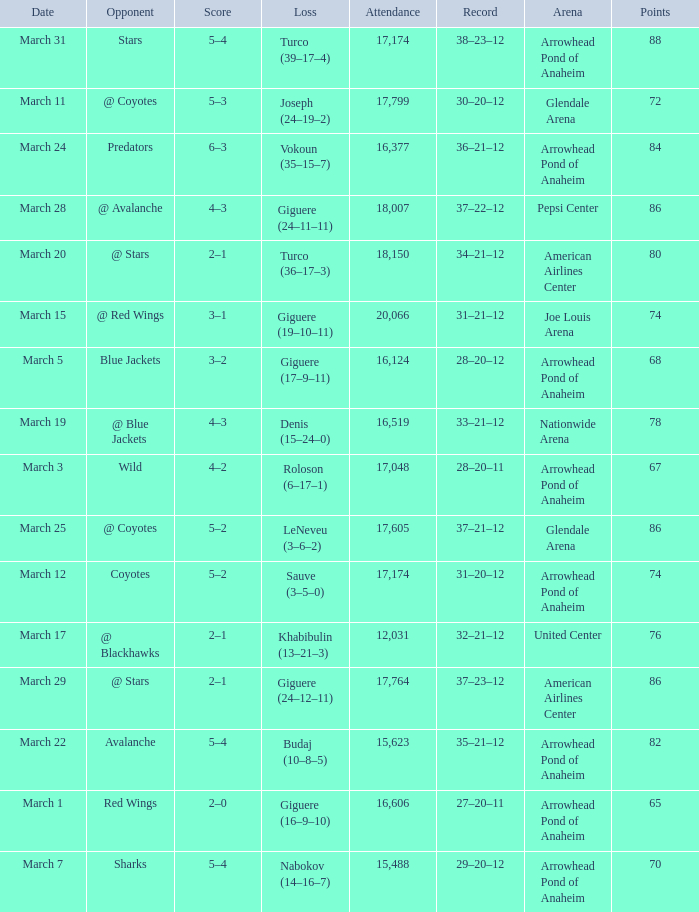What is the Record of the game with an Attendance of more than 16,124 and a Score of 6–3? 36–21–12. 